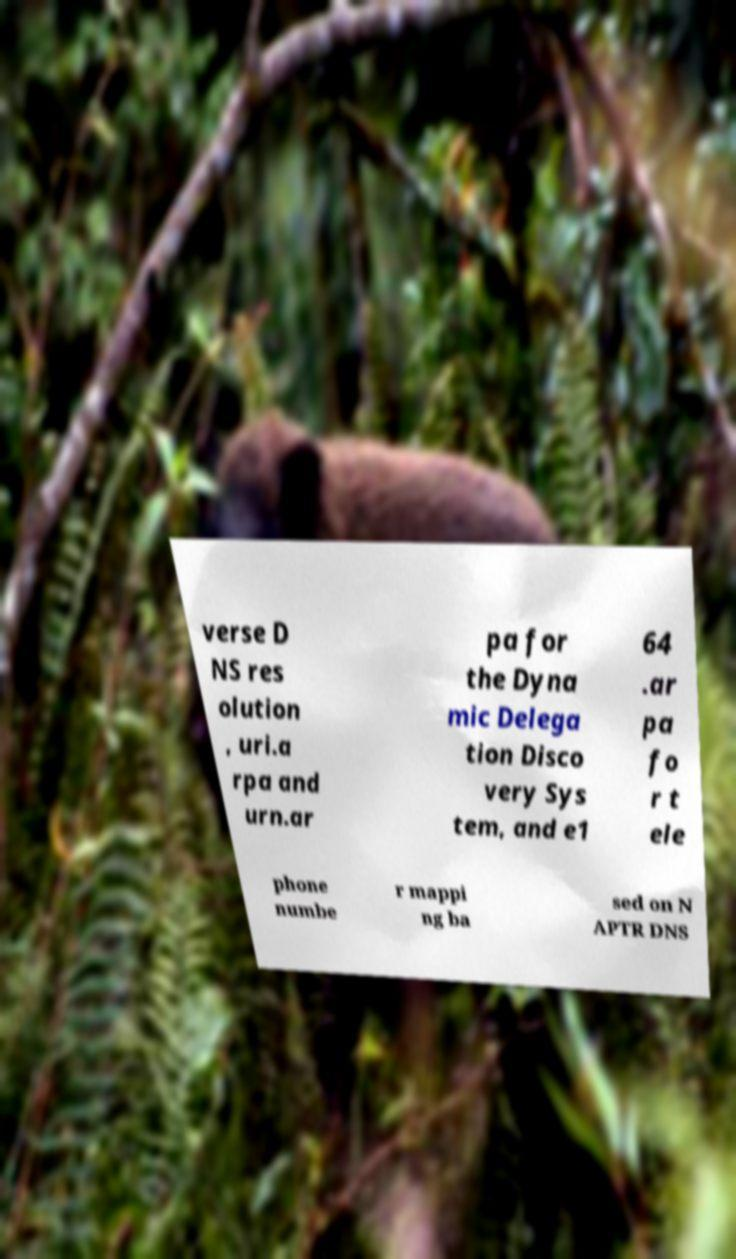Please read and relay the text visible in this image. What does it say? verse D NS res olution , uri.a rpa and urn.ar pa for the Dyna mic Delega tion Disco very Sys tem, and e1 64 .ar pa fo r t ele phone numbe r mappi ng ba sed on N APTR DNS 